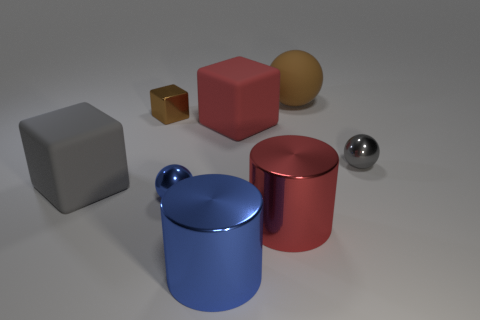Subtract all yellow blocks. Subtract all gray balls. How many blocks are left? 3 Add 1 small blue balls. How many objects exist? 9 Subtract all cylinders. How many objects are left? 6 Subtract all big yellow metallic spheres. Subtract all large blue cylinders. How many objects are left? 7 Add 7 large rubber blocks. How many large rubber blocks are left? 9 Add 4 small metal objects. How many small metal objects exist? 7 Subtract 0 green cylinders. How many objects are left? 8 